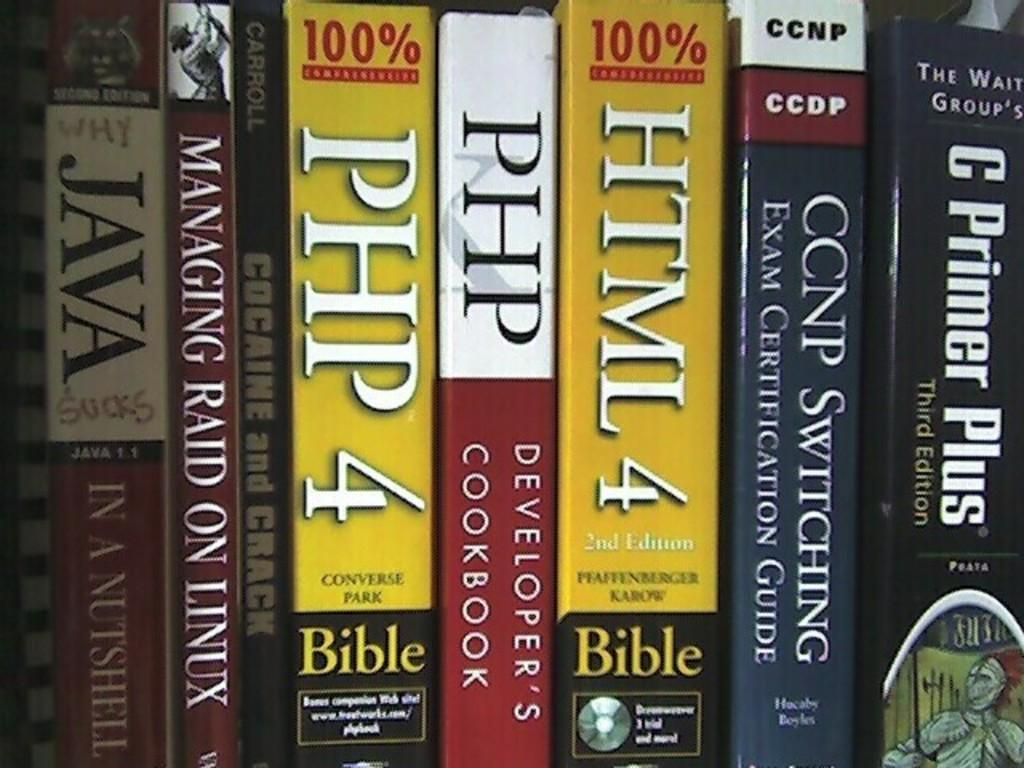<image>
Create a compact narrative representing the image presented. Some books, two of which have the word bible on them. 